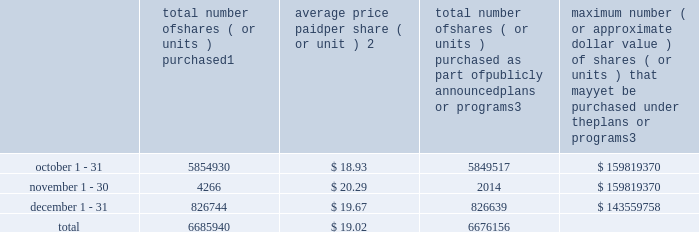Transfer agent and registrar for common stock the transfer agent and registrar for our common stock is : computershare shareowner services llc 480 washington boulevard 29th floor jersey city , new jersey 07310 telephone : ( 877 ) 363-6398 sales of unregistered securities not applicable .
Repurchase of equity securities the table provides information regarding our purchases of our equity securities during the period from october 1 , 2014 to december 31 , 2014 .
Total number of shares ( or units ) purchased 1 average price paid per share ( or unit ) 2 total number of shares ( or units ) purchased as part of publicly announced plans or programs 3 maximum number ( or approximate dollar value ) of shares ( or units ) that may yet be purchased under the plans or programs 3 .
1 included shares of our common stock , par value $ 0.10 per share , withheld under the terms of grants under employee stock-based compensation plans to offset tax withholding obligations that occurred upon vesting and release of restricted shares ( the 201cwithheld shares 201d ) .
We repurchased 5413 withheld shares in october 2014 , 4266 withheld shares in november 2014 and 105 withheld shares in december 2014 .
2 the average price per share for each of the months in the fiscal quarter and for the three-month period was calculated by dividing the sum of the applicable period of the aggregate value of the tax withholding obligations and the aggregate amount we paid for shares acquired under our stock repurchase program , described in note 5 to the consolidated financial statements , by the sum of the number of withheld shares and the number of shares acquired in our stock repurchase program .
3 in february 2014 , the board authorized a new share repurchase program to repurchase from time to time up to $ 300.0 million , excluding fees , of our common stock ( the 201c2014 share repurchase program 201d ) .
On february 13 , 2015 , we announced that our board had approved a new share repurchase program to repurchase from time to time up to $ 300.0 million , excluding fees , of our common stock .
The new authorization is in addition to any amounts remaining available for repurchase under the 2014 share repurchase program .
There is no expiration date associated with the share repurchase programs. .
What was the percent of the total number of shares purchased in october? 
Computations: (5854930 / 6685940)
Answer: 0.87571. 